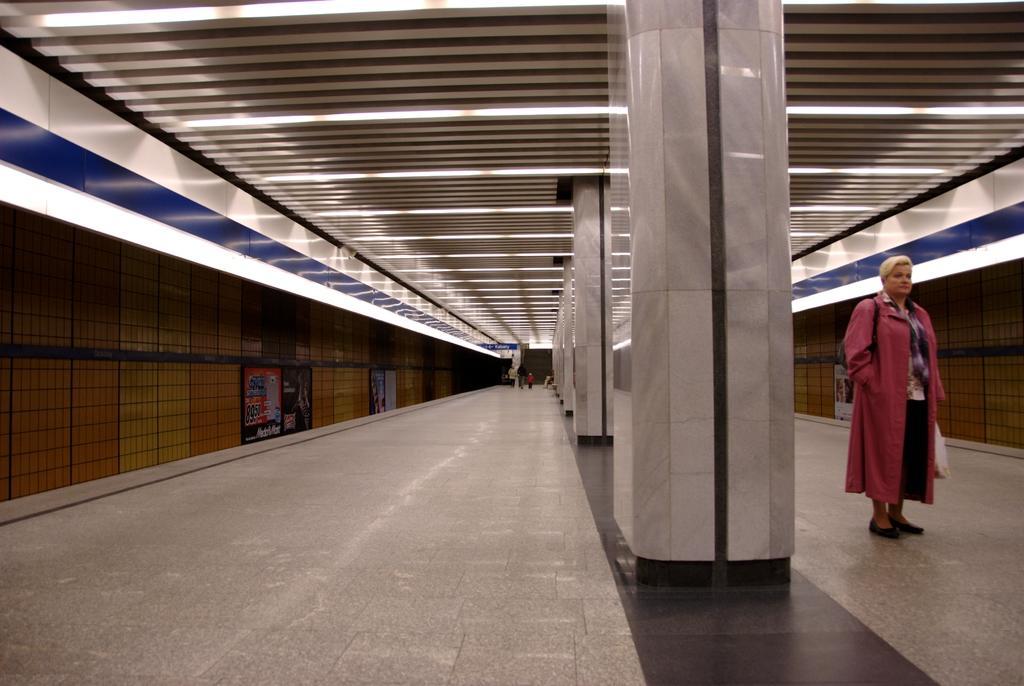In one or two sentences, can you explain what this image depicts? In this picture we can see people are walking on a path, we can see lights to the roof and we can see fencing and pillar. 